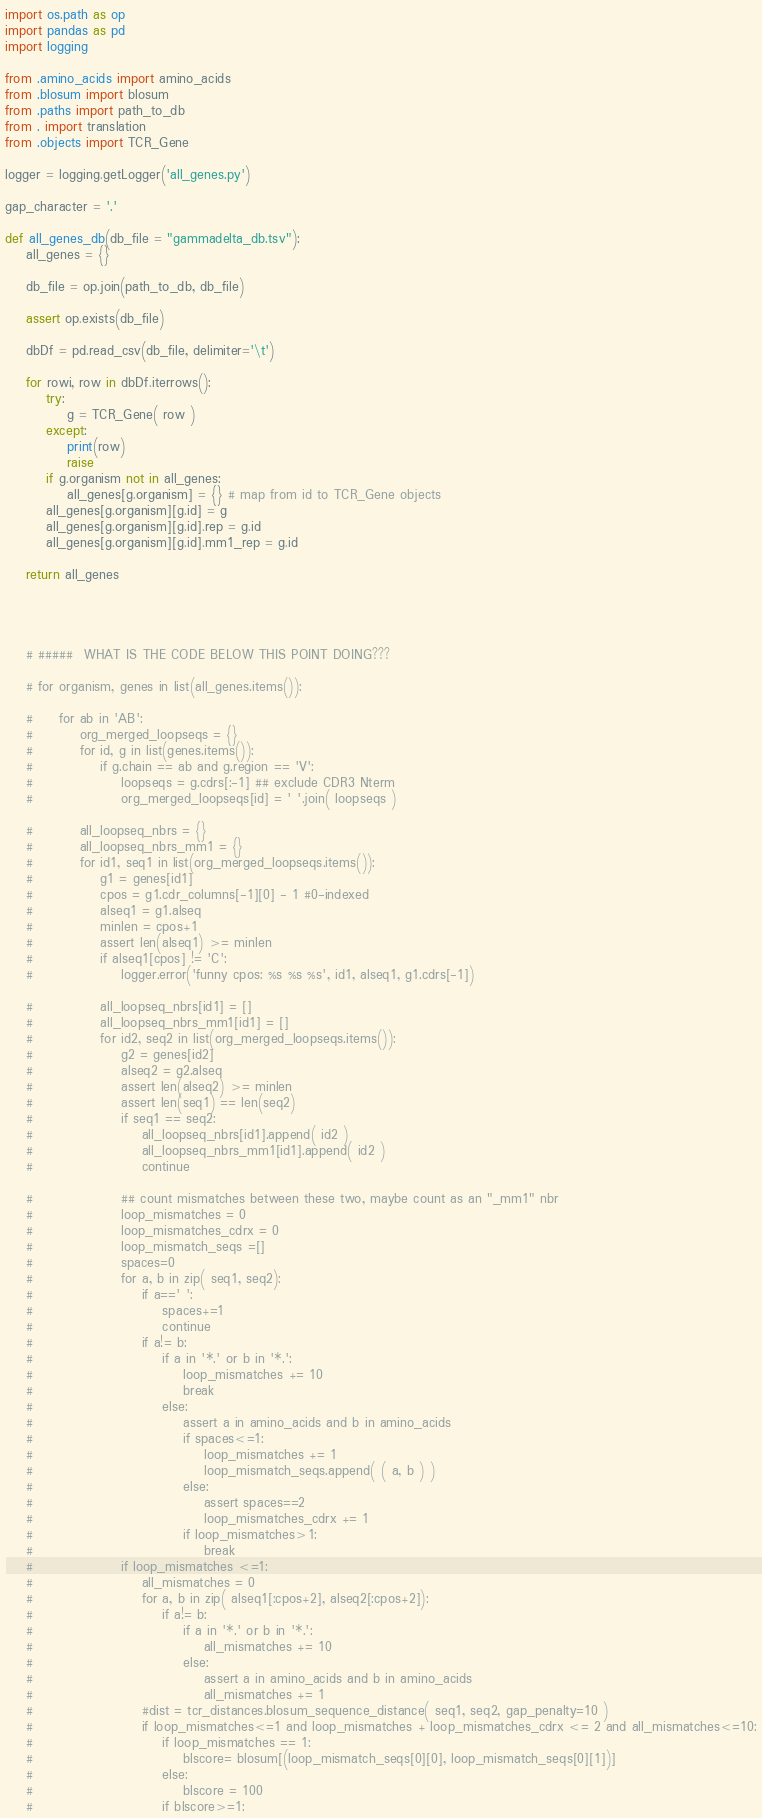Convert code to text. <code><loc_0><loc_0><loc_500><loc_500><_Python_>import os.path as op
import pandas as pd
import logging

from .amino_acids import amino_acids
from .blosum import blosum
from .paths import path_to_db
from . import translation
from .objects import TCR_Gene

logger = logging.getLogger('all_genes.py')

gap_character = '.'

def all_genes_db(db_file = "gammadelta_db.tsv"):
    all_genes = {}

    db_file = op.join(path_to_db, db_file)

    assert op.exists(db_file)

    dbDf = pd.read_csv(db_file, delimiter='\t')

    for rowi, row in dbDf.iterrows():
        try:
            g = TCR_Gene( row )
        except:
            print(row)
            raise
        if g.organism not in all_genes:
            all_genes[g.organism] = {} # map from id to TCR_Gene objects
        all_genes[g.organism][g.id] = g
        all_genes[g.organism][g.id].rep = g.id
        all_genes[g.organism][g.id].mm1_rep = g.id
    
    return all_genes




    # #####  WHAT IS THE CODE BELOW THIS POINT DOING??? 

    # for organism, genes in list(all_genes.items()):

    #     for ab in 'AB':
    #         org_merged_loopseqs = {}
    #         for id, g in list(genes.items()):
    #             if g.chain == ab and g.region == 'V':
    #                 loopseqs = g.cdrs[:-1] ## exclude CDR3 Nterm
    #                 org_merged_loopseqs[id] = ' '.join( loopseqs )

    #         all_loopseq_nbrs = {}
    #         all_loopseq_nbrs_mm1 = {}
    #         for id1, seq1 in list(org_merged_loopseqs.items()):
    #             g1 = genes[id1]
    #             cpos = g1.cdr_columns[-1][0] - 1 #0-indexed
    #             alseq1 = g1.alseq
    #             minlen = cpos+1
    #             assert len(alseq1) >= minlen
    #             if alseq1[cpos] != 'C':
    #                 logger.error('funny cpos: %s %s %s', id1, alseq1, g1.cdrs[-1])

    #             all_loopseq_nbrs[id1] = []
    #             all_loopseq_nbrs_mm1[id1] = []
    #             for id2, seq2 in list(org_merged_loopseqs.items()):
    #                 g2 = genes[id2]
    #                 alseq2 = g2.alseq
    #                 assert len(alseq2) >= minlen
    #                 assert len(seq1) == len(seq2)
    #                 if seq1 == seq2:
    #                     all_loopseq_nbrs[id1].append( id2 )
    #                     all_loopseq_nbrs_mm1[id1].append( id2 )
    #                     continue

    #                 ## count mismatches between these two, maybe count as an "_mm1" nbr
    #                 loop_mismatches = 0
    #                 loop_mismatches_cdrx = 0
    #                 loop_mismatch_seqs =[]
    #                 spaces=0
    #                 for a, b in zip( seq1, seq2):
    #                     if a==' ':
    #                         spaces+=1
    #                         continue
    #                     if a!= b:
    #                         if a in '*.' or b in '*.':
    #                             loop_mismatches += 10
    #                             break
    #                         else:
    #                             assert a in amino_acids and b in amino_acids
    #                             if spaces<=1:
    #                                 loop_mismatches += 1
    #                                 loop_mismatch_seqs.append( ( a, b ) )
    #                             else:
    #                                 assert spaces==2
    #                                 loop_mismatches_cdrx += 1
    #                             if loop_mismatches>1:
    #                                 break
    #                 if loop_mismatches <=1:
    #                     all_mismatches = 0
    #                     for a, b in zip( alseq1[:cpos+2], alseq2[:cpos+2]):
    #                         if a!= b:
    #                             if a in '*.' or b in '*.':
    #                                 all_mismatches += 10
    #                             else:
    #                                 assert a in amino_acids and b in amino_acids
    #                                 all_mismatches += 1
    #                     #dist = tcr_distances.blosum_sequence_distance( seq1, seq2, gap_penalty=10 )
    #                     if loop_mismatches<=1 and loop_mismatches + loop_mismatches_cdrx <= 2 and all_mismatches<=10:
    #                         if loop_mismatches == 1:
    #                             blscore= blosum[(loop_mismatch_seqs[0][0], loop_mismatch_seqs[0][1])]
    #                         else:
    #                             blscore = 100
    #                         if blscore>=1:</code> 